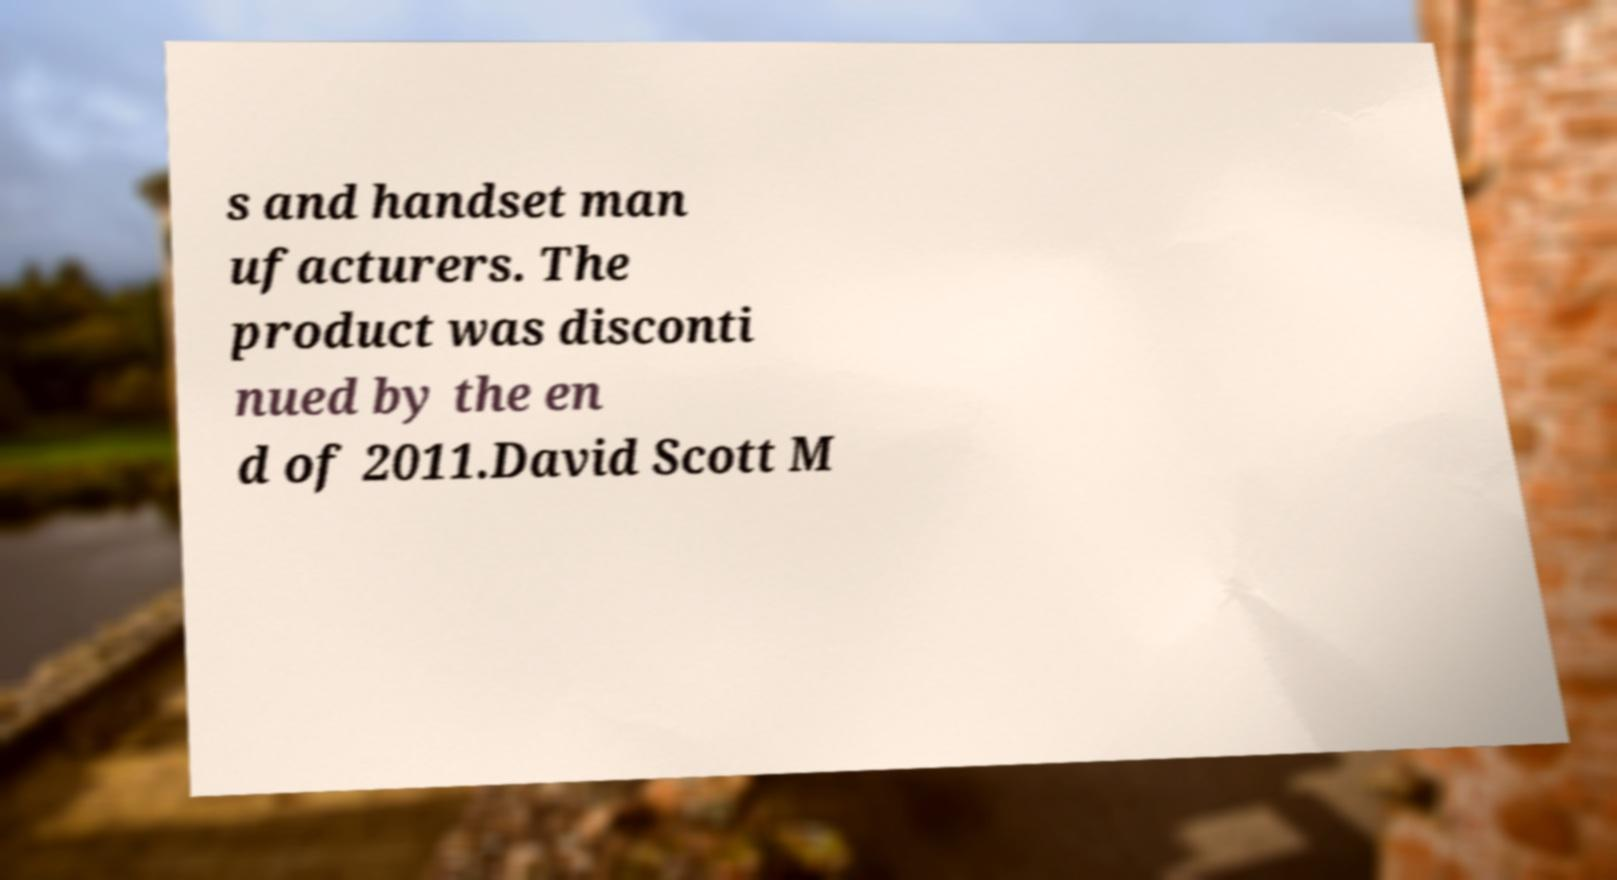What messages or text are displayed in this image? I need them in a readable, typed format. s and handset man ufacturers. The product was disconti nued by the en d of 2011.David Scott M 